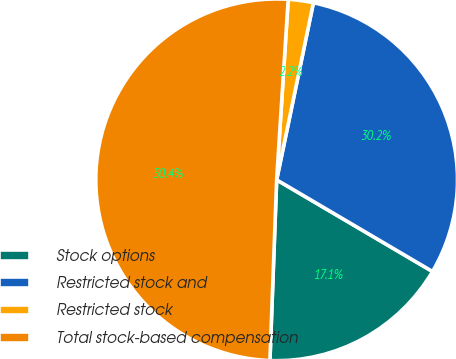Convert chart. <chart><loc_0><loc_0><loc_500><loc_500><pie_chart><fcel>Stock options<fcel>Restricted stock and<fcel>Restricted stock<fcel>Total stock-based compensation<nl><fcel>17.13%<fcel>30.21%<fcel>2.24%<fcel>50.43%<nl></chart> 